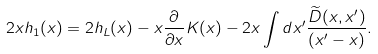<formula> <loc_0><loc_0><loc_500><loc_500>2 x h _ { 1 } ( x ) = 2 h _ { L } ( x ) - x \frac { \partial } { \partial x } K ( x ) - 2 x \int d x ^ { \prime } \frac { \widetilde { D } ( x , x ^ { \prime } ) } { ( x ^ { \prime } - x ) } .</formula> 